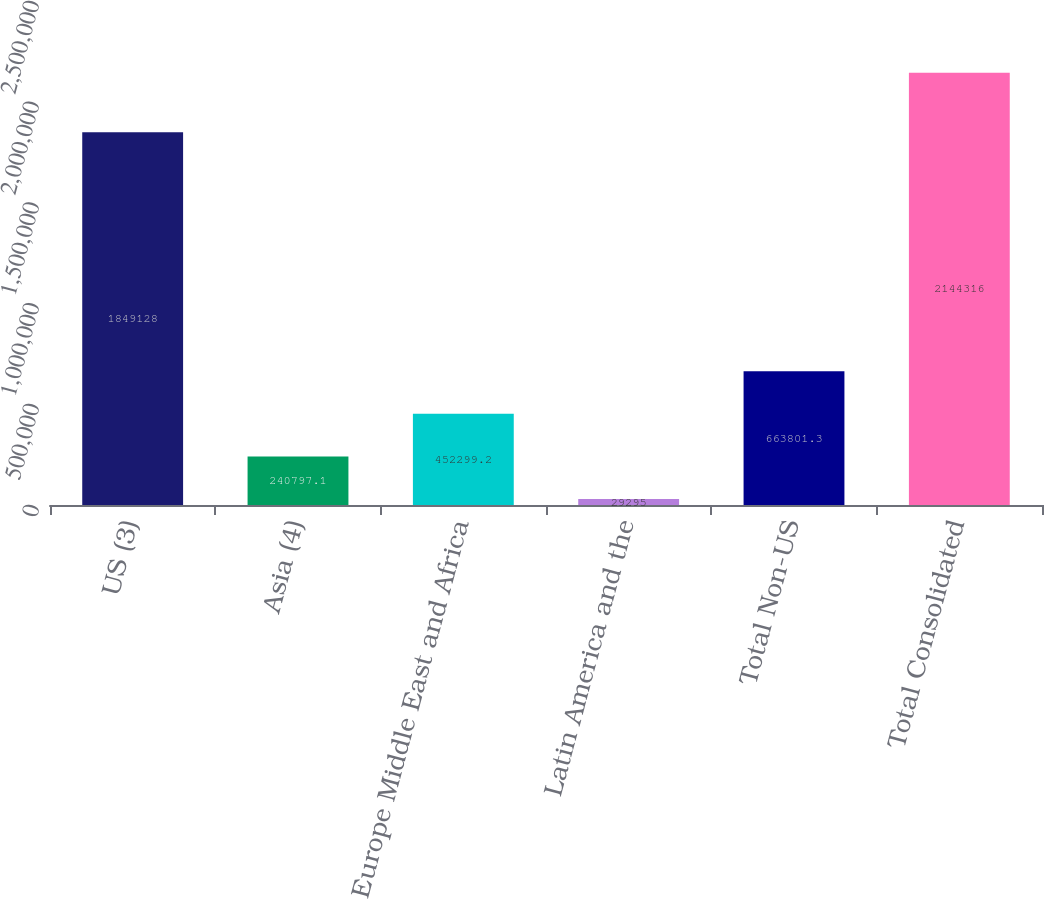<chart> <loc_0><loc_0><loc_500><loc_500><bar_chart><fcel>US (3)<fcel>Asia (4)<fcel>Europe Middle East and Africa<fcel>Latin America and the<fcel>Total Non-US<fcel>Total Consolidated<nl><fcel>1.84913e+06<fcel>240797<fcel>452299<fcel>29295<fcel>663801<fcel>2.14432e+06<nl></chart> 